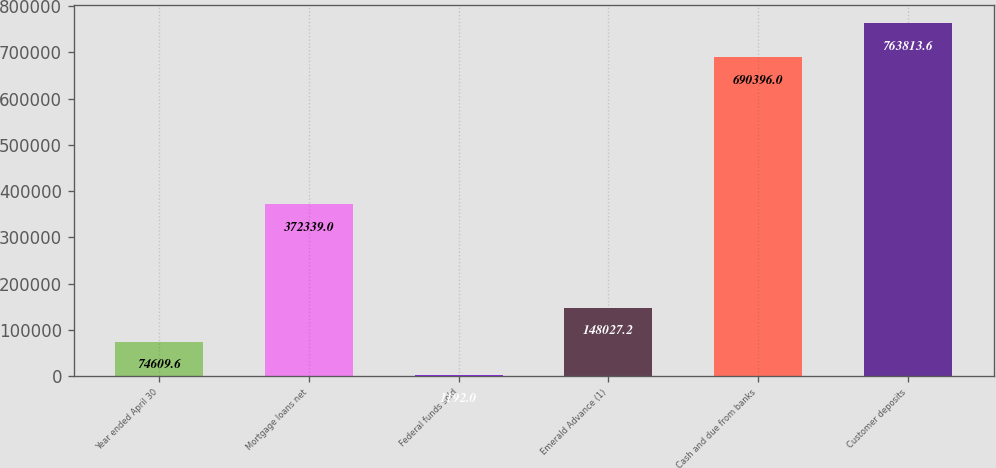<chart> <loc_0><loc_0><loc_500><loc_500><bar_chart><fcel>Year ended April 30<fcel>Mortgage loans net<fcel>Federal funds sold<fcel>Emerald Advance (1)<fcel>Cash and due from banks<fcel>Customer deposits<nl><fcel>74609.6<fcel>372339<fcel>1192<fcel>148027<fcel>690396<fcel>763814<nl></chart> 